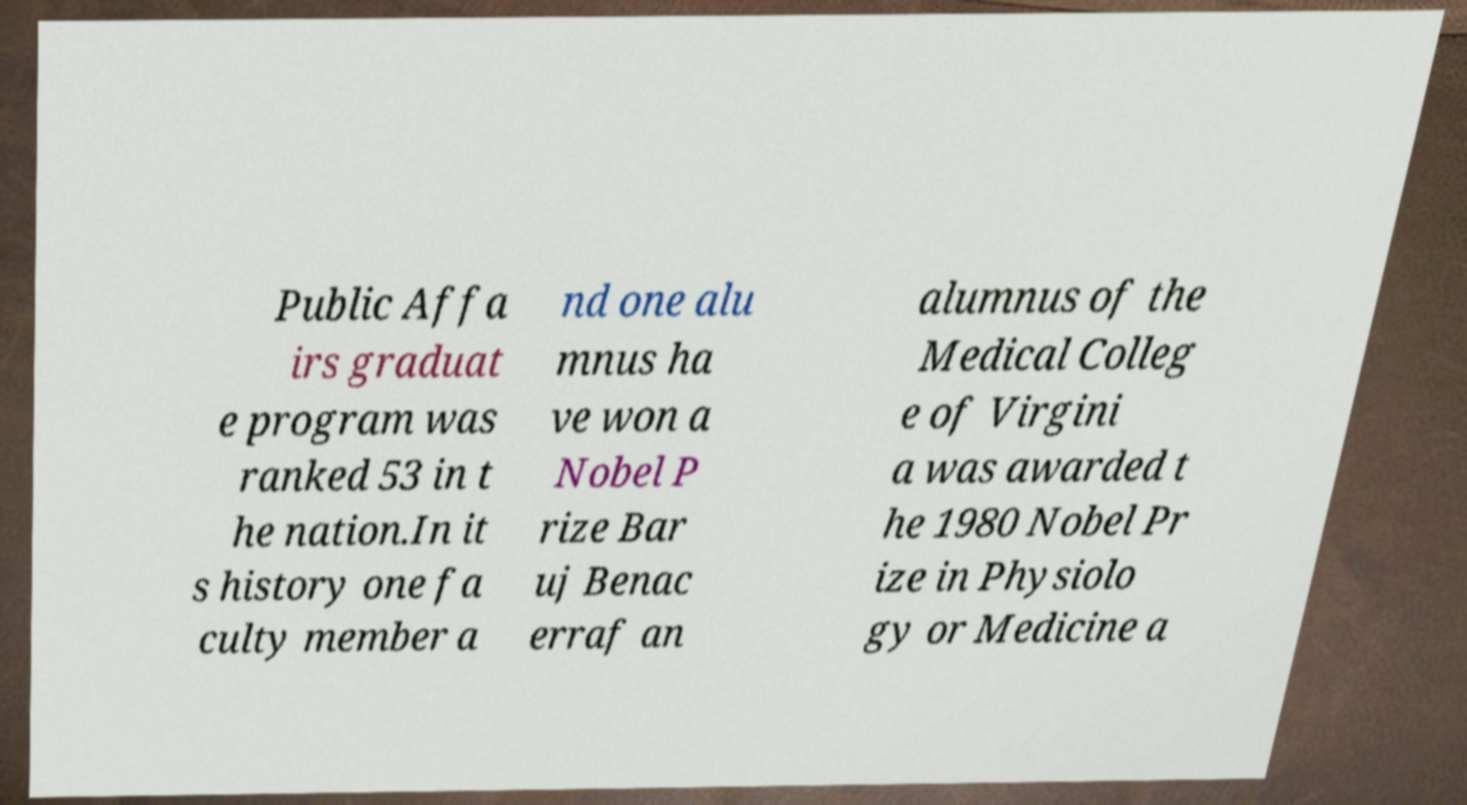Please identify and transcribe the text found in this image. Public Affa irs graduat e program was ranked 53 in t he nation.In it s history one fa culty member a nd one alu mnus ha ve won a Nobel P rize Bar uj Benac erraf an alumnus of the Medical Colleg e of Virgini a was awarded t he 1980 Nobel Pr ize in Physiolo gy or Medicine a 